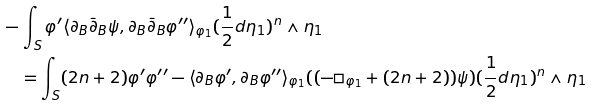<formula> <loc_0><loc_0><loc_500><loc_500>& - \int _ { S } \varphi ^ { \prime } \langle \partial _ { B } \bar { \partial } _ { B } \psi , \partial _ { B } \bar { \partial } _ { B } \varphi ^ { \prime \prime } \rangle _ { \varphi _ { 1 } } ( \frac { 1 } { 2 } d \eta _ { 1 } ) ^ { n } \wedge \eta _ { 1 } \\ & \quad = \int _ { S } ( 2 n + 2 ) \varphi ^ { \prime } \varphi ^ { \prime \prime } - \langle \partial _ { B } \varphi ^ { \prime } , \partial _ { B } \varphi ^ { \prime \prime } \rangle _ { \varphi _ { 1 } } ( ( - \Box _ { \varphi _ { 1 } } + ( 2 n + 2 ) ) \psi ) ( \frac { 1 } { 2 } d \eta _ { 1 } ) ^ { n } \wedge \eta _ { 1 }</formula> 